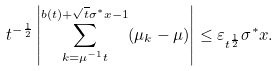<formula> <loc_0><loc_0><loc_500><loc_500>t ^ { - \frac { 1 } { 2 } } \left | \sum _ { k = \mu ^ { - 1 } t } ^ { b ( t ) + \sqrt { t } \sigma ^ { * } x - 1 } ( \mu _ { k } - \mu ) \right | \leq \varepsilon _ { t ^ { \frac { 1 } { 2 } } } \sigma ^ { * } x .</formula> 